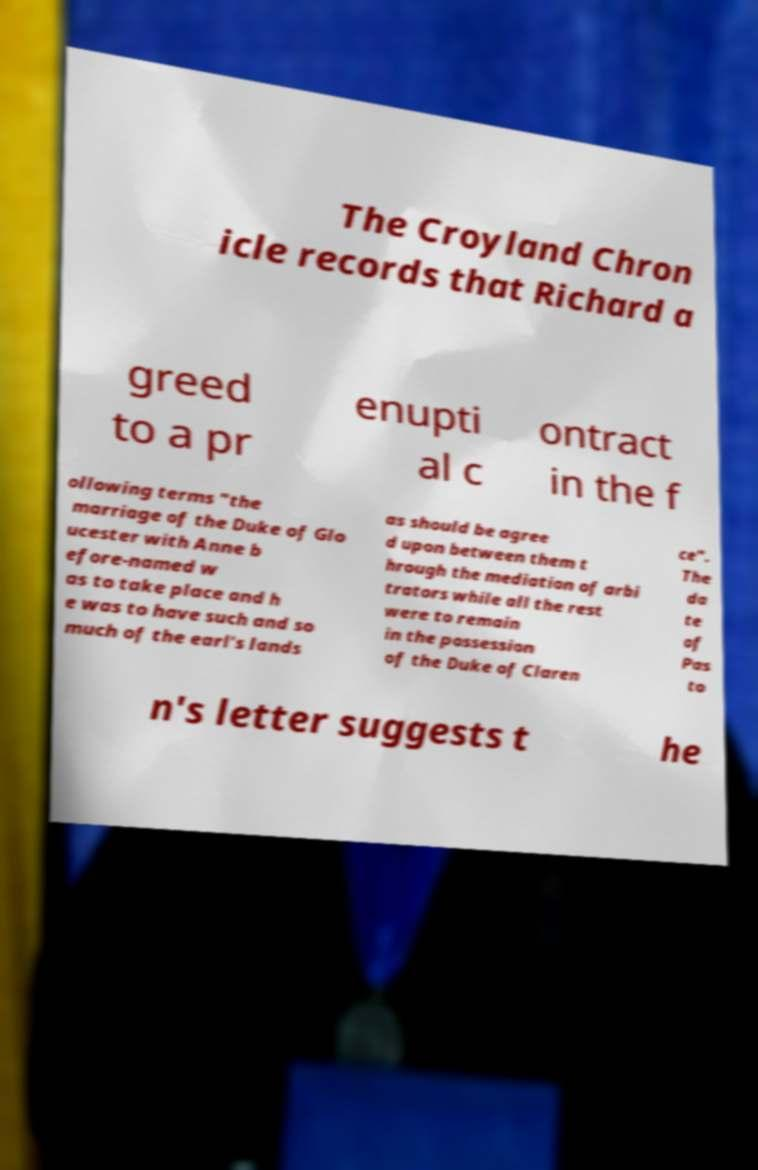Please read and relay the text visible in this image. What does it say? The Croyland Chron icle records that Richard a greed to a pr enupti al c ontract in the f ollowing terms "the marriage of the Duke of Glo ucester with Anne b efore-named w as to take place and h e was to have such and so much of the earl's lands as should be agree d upon between them t hrough the mediation of arbi trators while all the rest were to remain in the possession of the Duke of Claren ce". The da te of Pas to n's letter suggests t he 